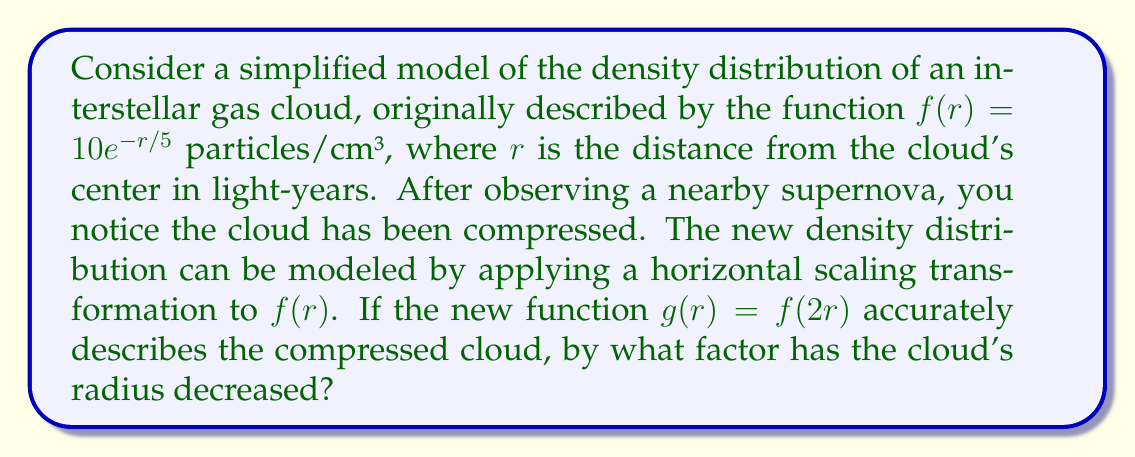What is the answer to this math problem? Let's approach this step-by-step:

1) The original function is $f(r) = 10e^{-r/5}$.

2) The new function after transformation is $g(r) = f(2r) = 10e^{-2r/5}$.

3) To understand the scaling, let's consider how the argument of the function has changed:
   - In $f(r)$, the argument is $r$
   - In $g(r)$, the argument is $2r$

4) This means that for any given density value, the corresponding $r$ value in $g(r)$ is half of what it would be in $f(r)$.

5) For example, if we want to find where the density is 5 particles/cm³:
   - In $f(r)$: $5 = 10e^{-r/5}$ → $r = 5\ln(2) \approx 3.47$ light-years
   - In $g(r)$: $5 = 10e^{-2r/5}$ → $r = \frac{5}{2}\ln(2) \approx 1.73$ light-years

6) The new $r$ value is exactly half of the original $r$ value.

7) This means the cloud's radius has been reduced by a factor of 2, or in other words, it has decreased to 1/2 of its original size.
Answer: 2 